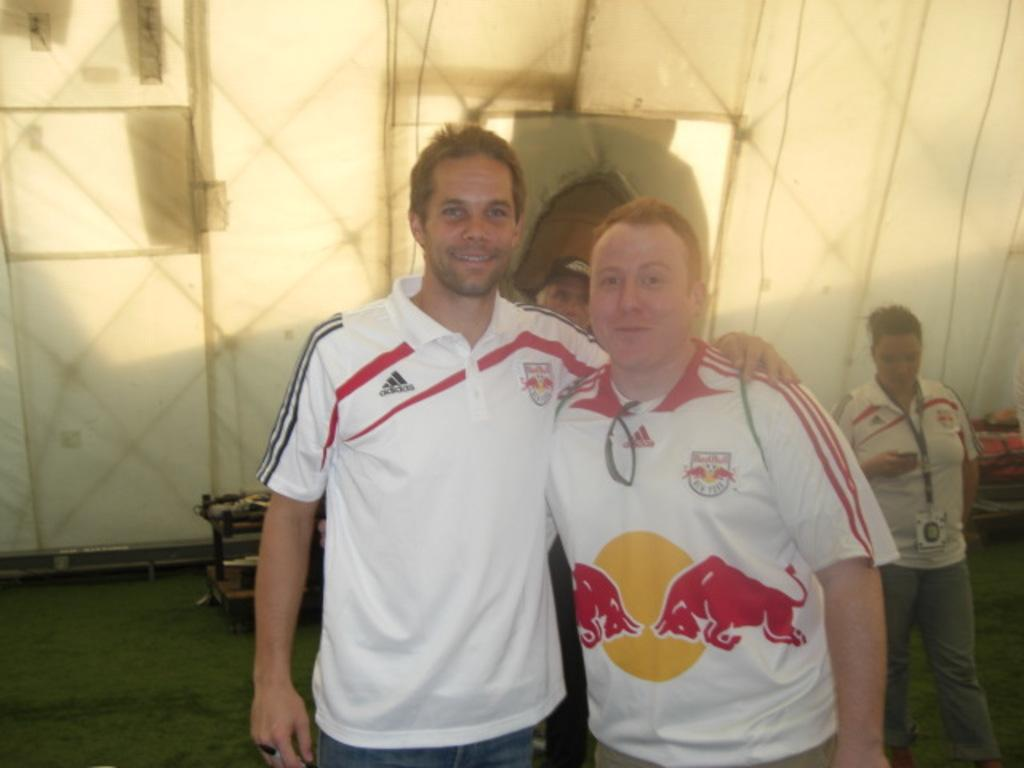How many men are standing in the foreground of the image? There are two men standing in the foreground of the image. What can be seen in the background of the image? In the background, there is a man standing on the grass, a woman standing on the grass, and a wall of a tent. How many people are visible in the background of the image? There are three people visible in the background of the image: a man, a woman, and a man standing near the tent. What is the general setting of the image? The image appears to be set in an outdoor area with a grassy background and a tent. Is there a stream running through the image? There is no stream visible in the image. What type of attraction is present in the background of the image? There is no attraction mentioned or visible in the image. 